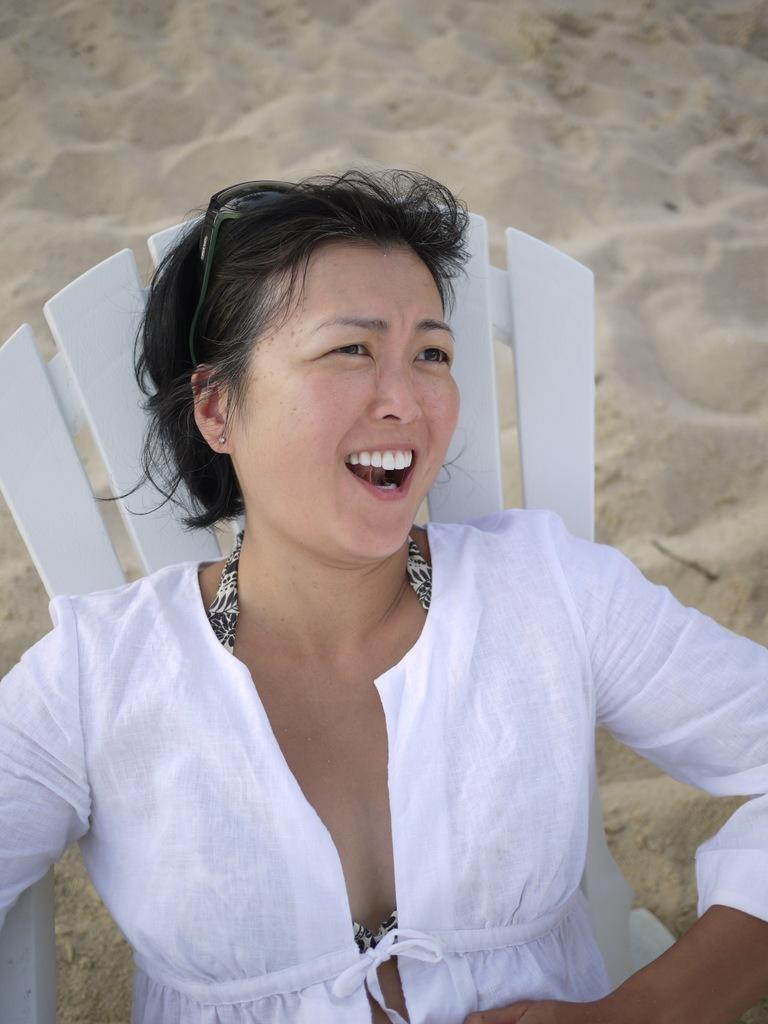Who is present in the image? There is a woman in the image. What is the woman wearing? The woman is wearing a white dress. What is the woman's facial expression? The woman is smiling. What is the woman's position in the image? The woman appears to be sitting on a chair. What can be seen in the background of the image? There is mud visible in the background of the image. What type of nut is the minister holding in the image? There is no minister or nut present in the image. How many feet can be seen in the image? The image only shows a woman sitting on a chair, and her feet are not visible. 